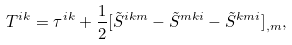<formula> <loc_0><loc_0><loc_500><loc_500>T ^ { i k } = \tau ^ { i k } + \frac { 1 } { 2 } [ \tilde { S } ^ { i k m } - \tilde { S } ^ { m k i } - \tilde { S } ^ { k m i } ] _ { , m } ,</formula> 